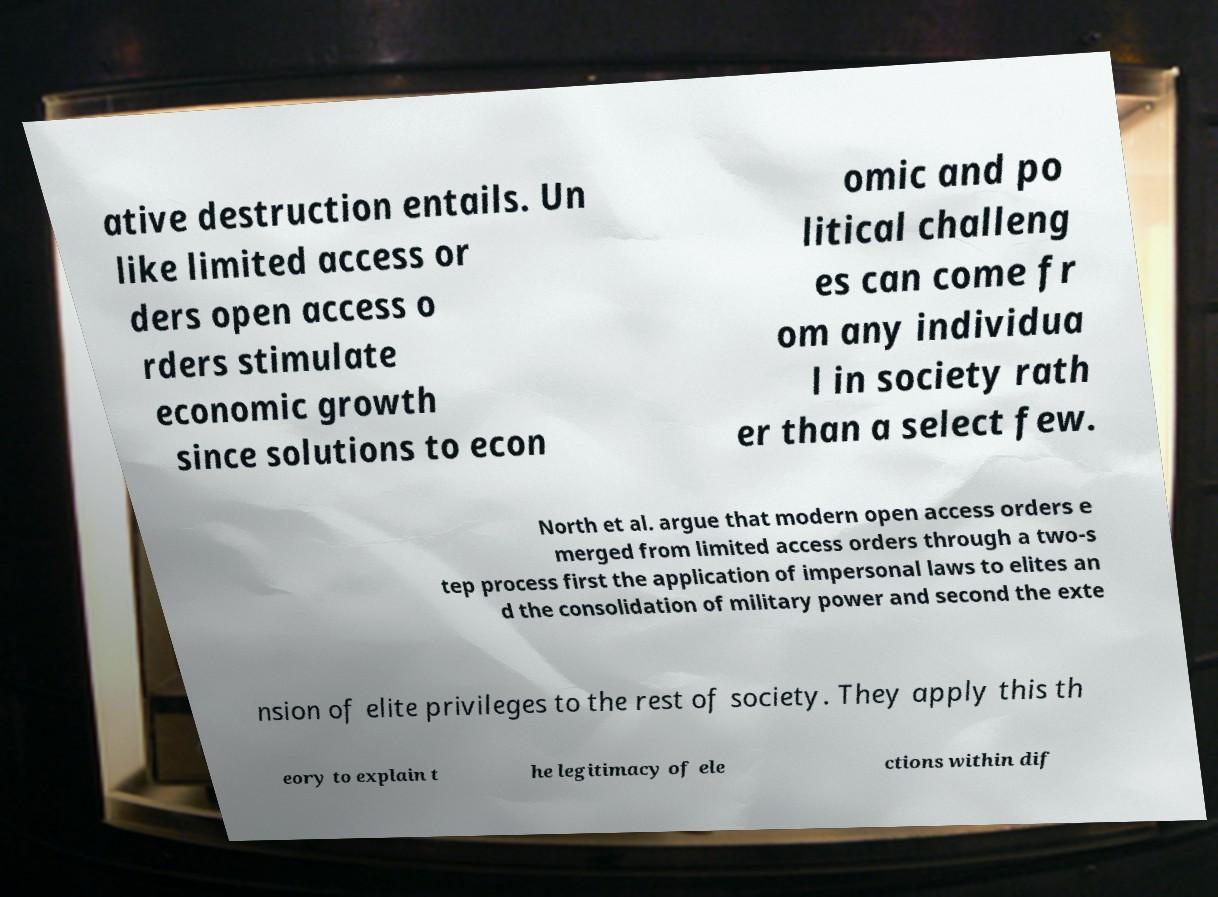For documentation purposes, I need the text within this image transcribed. Could you provide that? ative destruction entails. Un like limited access or ders open access o rders stimulate economic growth since solutions to econ omic and po litical challeng es can come fr om any individua l in society rath er than a select few. North et al. argue that modern open access orders e merged from limited access orders through a two-s tep process first the application of impersonal laws to elites an d the consolidation of military power and second the exte nsion of elite privileges to the rest of society. They apply this th eory to explain t he legitimacy of ele ctions within dif 